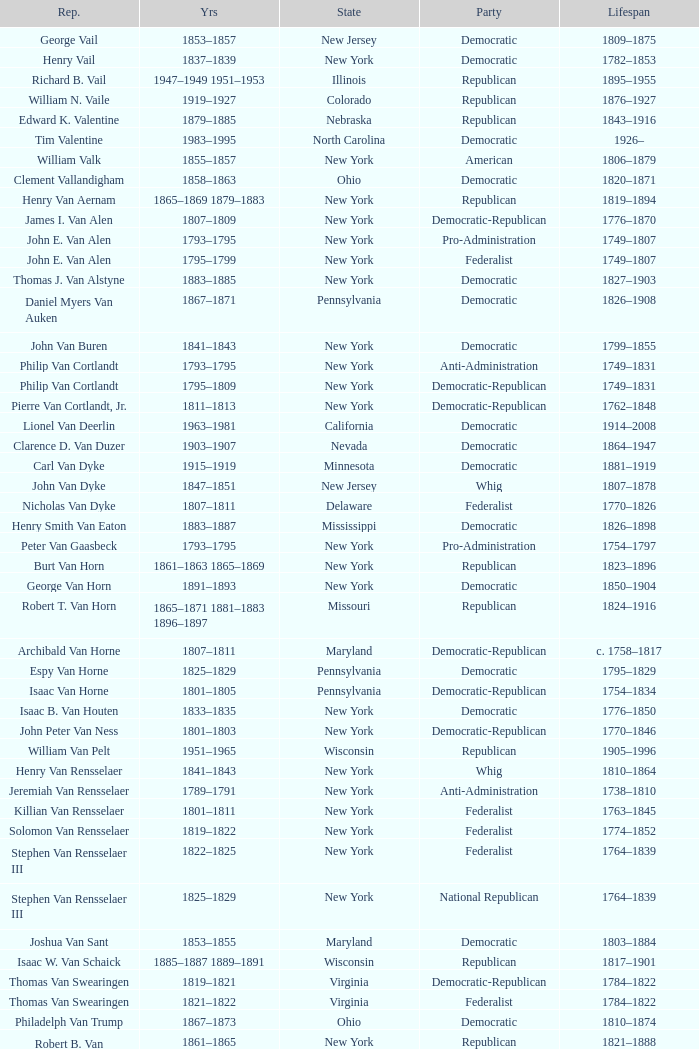What is the lifespan of Joseph Vance, a democratic-republican from Ohio? 1786–1852. 